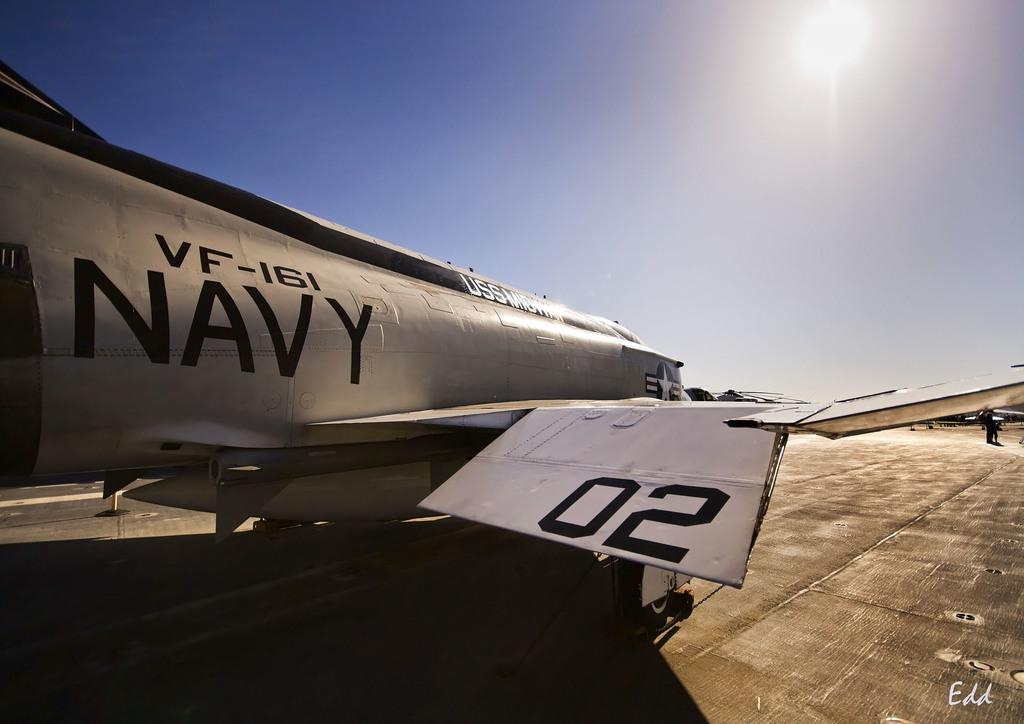<image>
Render a clear and concise summary of the photo. A Navy VF-161 jet is parked on concrete. 